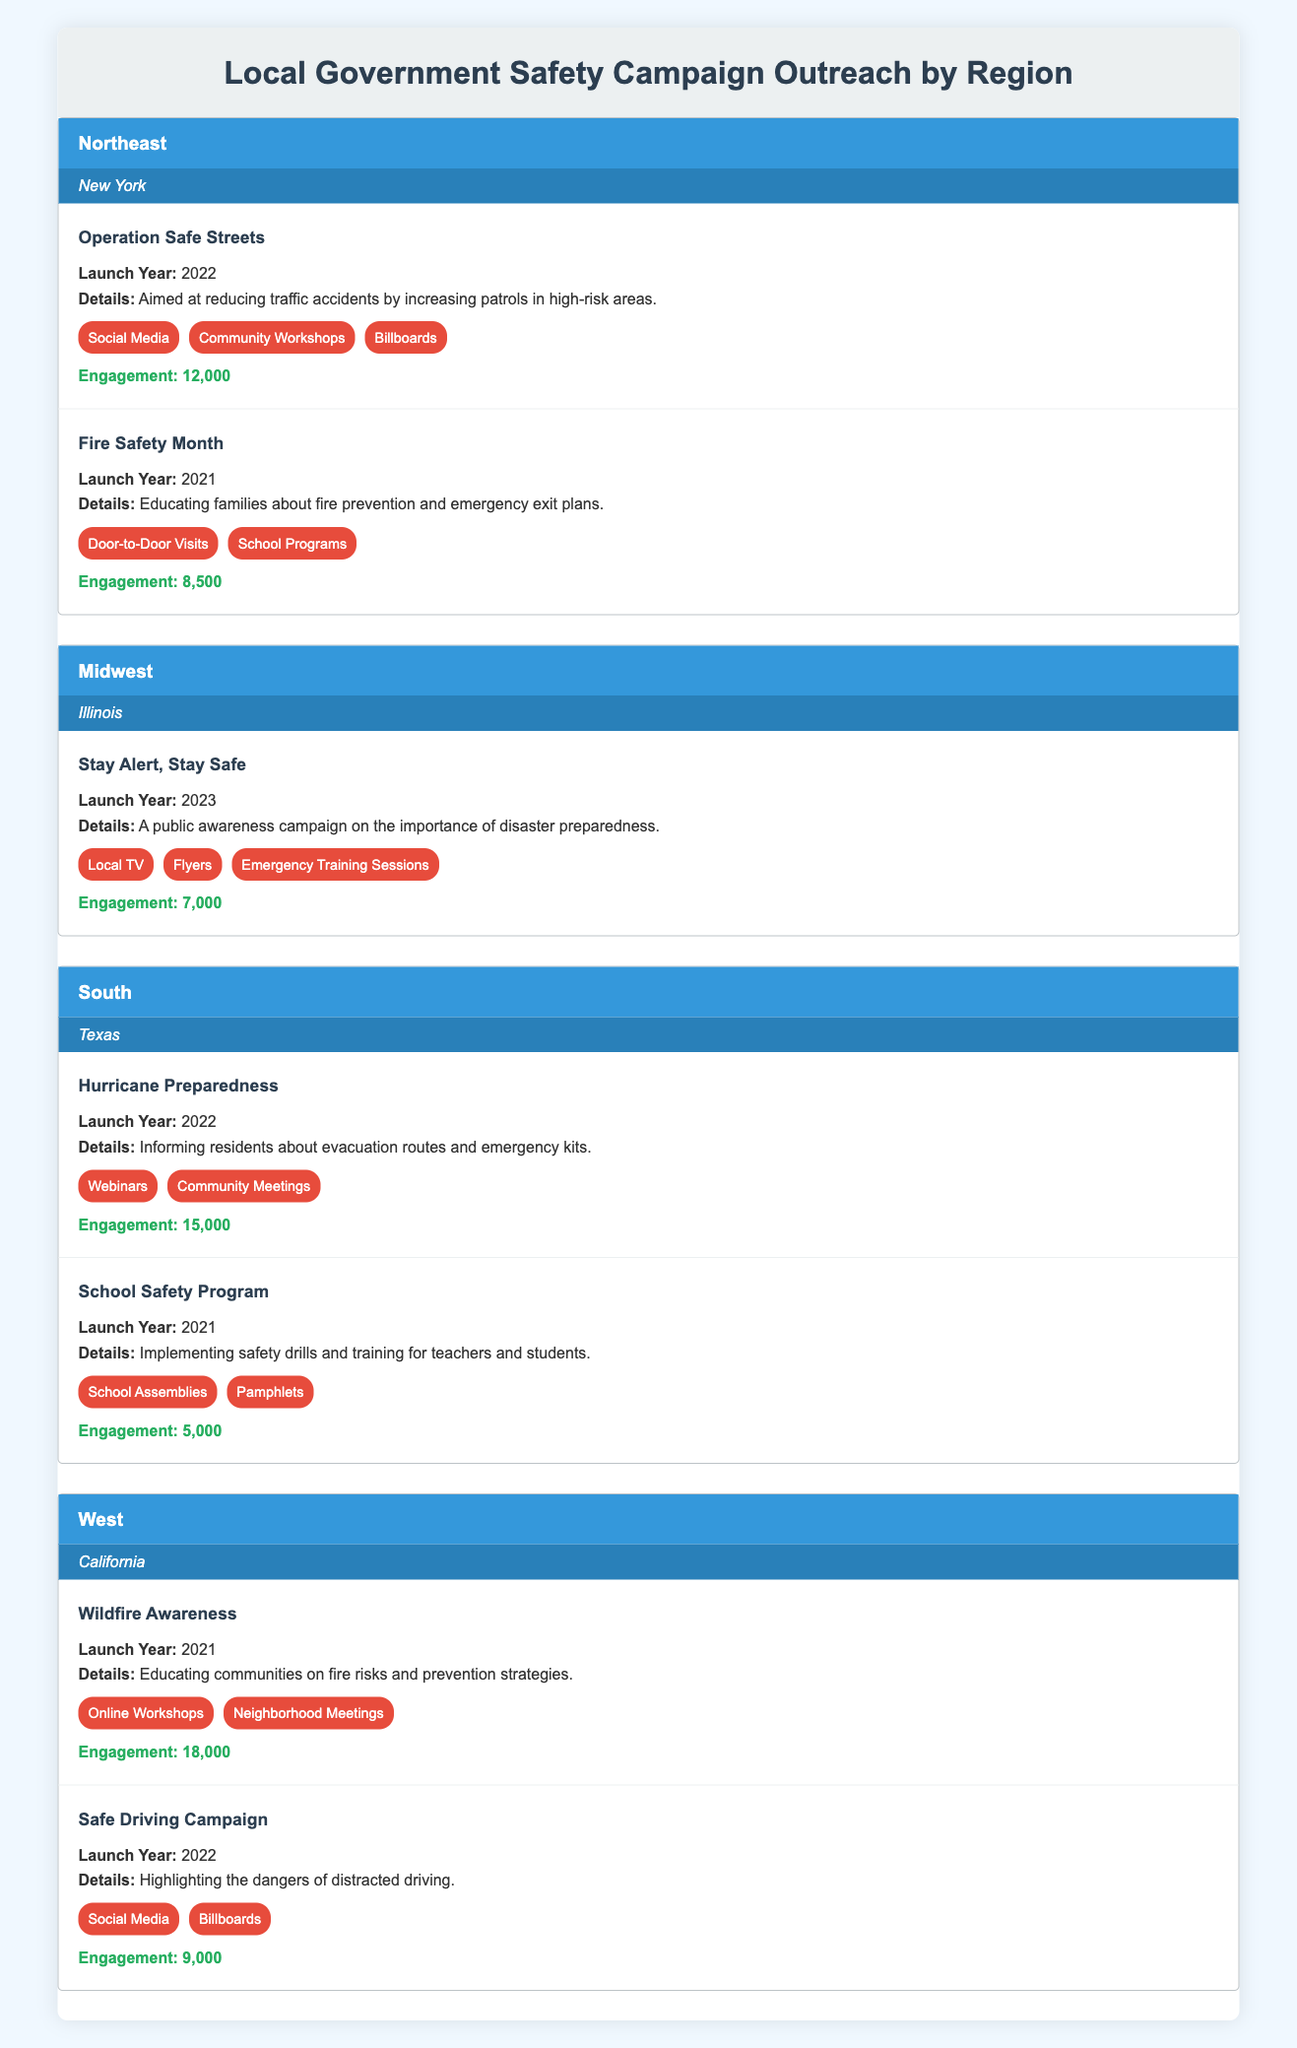What is the total engagement for all campaigns in the South region? The South region has two campaigns: Hurricane Preparedness with an engagement of 15,000 and School Safety Program with an engagement of 5,000. We need to sum these two values: 15,000 + 5,000 = 20,000.
Answer: 20,000 Which campaign in the Northeast had the highest engagement? In the Northeast region, Operation Safe Streets had an engagement of 12,000, while Fire Safety Month had an engagement of 8,500. Since 12,000 is greater than 8,500, Operation Safe Streets had the highest engagement.
Answer: Operation Safe Streets Did the Midwest region launch a campaign in 2022? In the Midwest region, there is only one campaign, Stay Alert, Stay Safe, which was launched in 2023. There are no campaigns from the Midwest region in 2022, making this statement false.
Answer: No What is the average engagement of campaigns in the West region? The West region has two campaigns: Wildfire Awareness (18,000) and Safe Driving Campaign (9,000). To find the average, we sum the engagements: 18,000 + 9,000 = 27,000. Then, we divide by the number of campaigns, which is 2: 27,000 / 2 = 13,500.
Answer: 13,500 Is there a campaign focused on disaster preparedness in the table? The Midwest region has the campaign Stay Alert, Stay Safe, which specifically focuses on disaster preparedness. Therefore, the answer to whether there is a campaign focused on this topic is yes.
Answer: Yes How many outreach methods were used for the Fire Safety Month campaign in the Northeast? The Fire Safety Month campaign had two outreach methods: Door-to-Door Visits and School Programs. Simply counting these methods gives us a total of 2 outreach methods for the campaign.
Answer: 2 Which region had the highest total engagement across all its campaigns? We need to calculate the total engagement for each region: Northeast (12,000 + 8,500 = 20,500), Midwest (7,000), South (20,000), and West (18,000 + 9,000 = 27,000). The highest total engagement is from the West region with 27,000.
Answer: West How many campaigns did the South region launch in total? The South region had two campaigns: Hurricane Preparedness and School Safety Program. Thus, the total number of campaigns launched in this region is 2.
Answer: 2 What is the difference in engagement between the most and least engaging campaigns in the Northeast? The Northeast’s highest engaging campaign is Operation Safe Streets (12,000), and the lowest is Fire Safety Month (8,500). The difference in engagement is calculated as 12,000 - 8,500 = 3,500.
Answer: 3,500 Which outreach method was used for the "Stay Alert, Stay Safe" campaign? The Stay Alert, Stay Safe campaign utilized three outreach methods: Local TV, Flyers, and Emergency Training Sessions. Therefore, the outreach methods used for this campaign are these three.
Answer: Local TV, Flyers, Emergency Training Sessions 